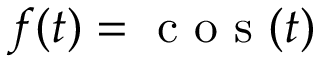Convert formula to latex. <formula><loc_0><loc_0><loc_500><loc_500>f ( t ) = c o s ( t )</formula> 